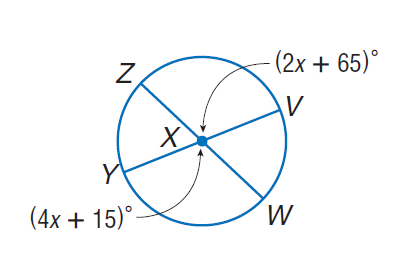Answer the mathemtical geometry problem and directly provide the correct option letter.
Question: Find m \angle Z X V.
Choices: A: 25 B: 65 C: 115 D: 130 C 